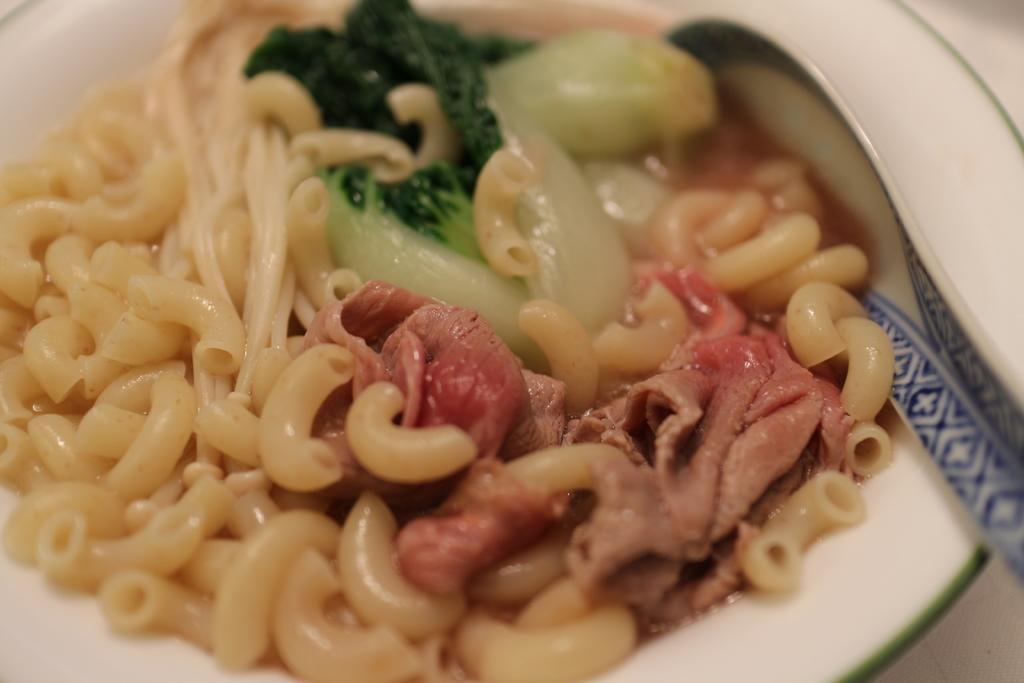Can you describe this image briefly? In this image there is a plate. On the plate there is a spoon and a food item with pastas, noodles, meat and some other items. 